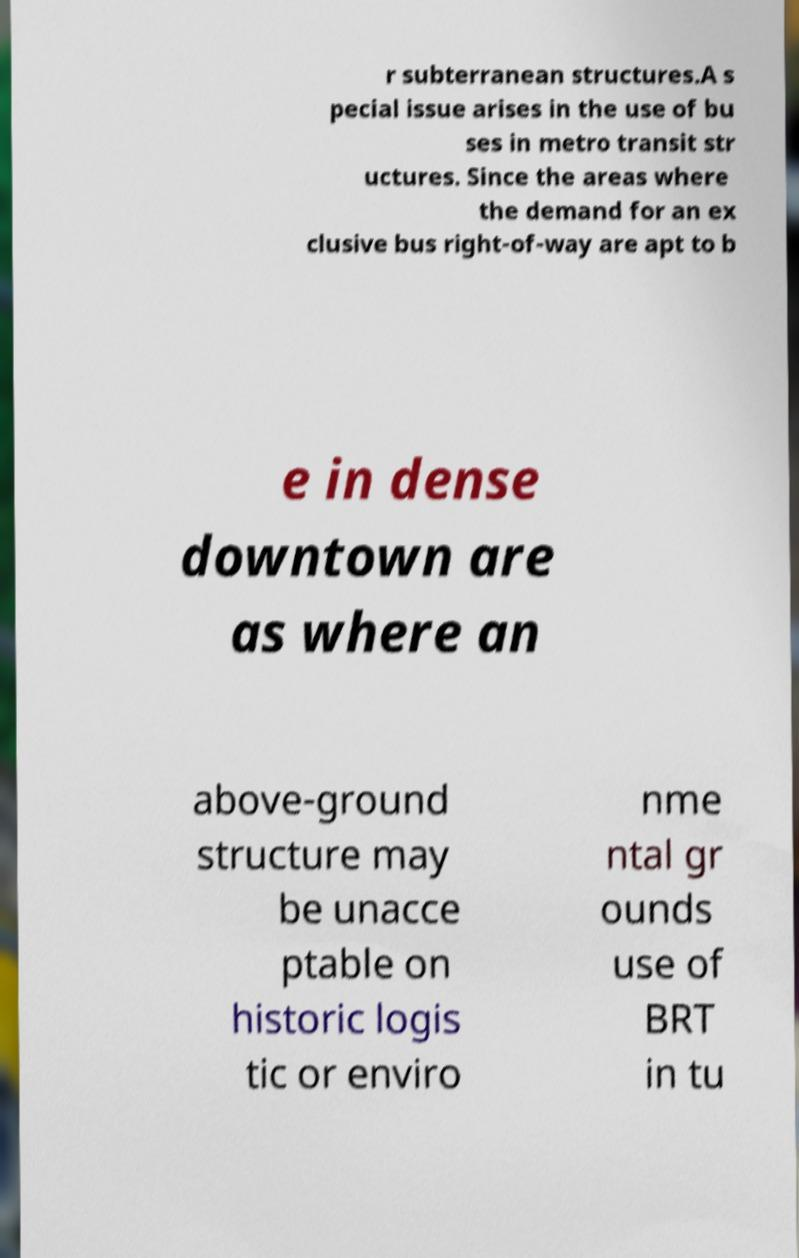Can you read and provide the text displayed in the image?This photo seems to have some interesting text. Can you extract and type it out for me? r subterranean structures.A s pecial issue arises in the use of bu ses in metro transit str uctures. Since the areas where the demand for an ex clusive bus right-of-way are apt to b e in dense downtown are as where an above-ground structure may be unacce ptable on historic logis tic or enviro nme ntal gr ounds use of BRT in tu 